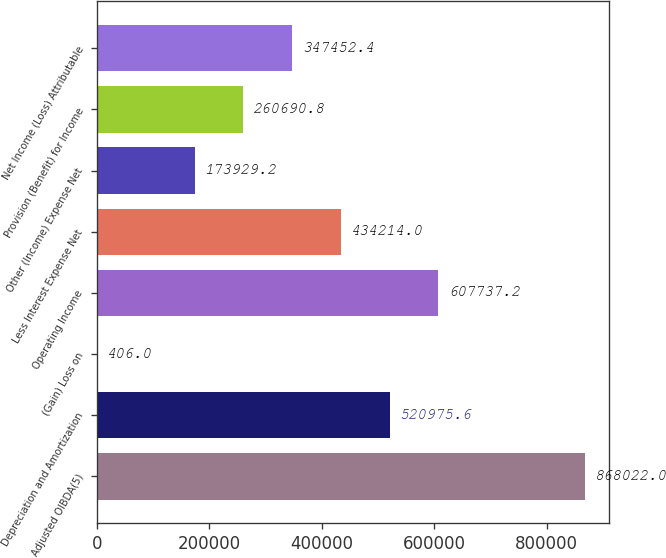<chart> <loc_0><loc_0><loc_500><loc_500><bar_chart><fcel>Adjusted OIBDA(5)<fcel>Depreciation and Amortization<fcel>(Gain) Loss on<fcel>Operating Income<fcel>Less Interest Expense Net<fcel>Other (Income) Expense Net<fcel>Provision (Benefit) for Income<fcel>Net Income (Loss) Attributable<nl><fcel>868022<fcel>520976<fcel>406<fcel>607737<fcel>434214<fcel>173929<fcel>260691<fcel>347452<nl></chart> 